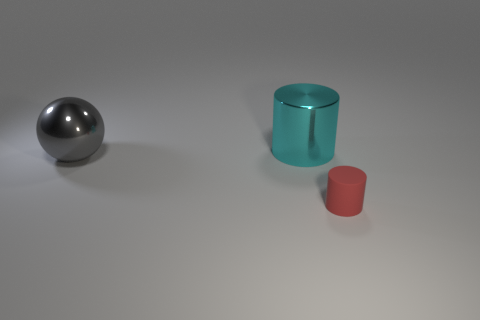Add 1 tiny purple shiny balls. How many objects exist? 4 Subtract all balls. How many objects are left? 2 Subtract all blue cylinders. Subtract all brown balls. How many cylinders are left? 2 Subtract all big cyan metallic objects. Subtract all tiny red matte cylinders. How many objects are left? 1 Add 3 gray balls. How many gray balls are left? 4 Add 2 big gray balls. How many big gray balls exist? 3 Subtract 0 purple blocks. How many objects are left? 3 